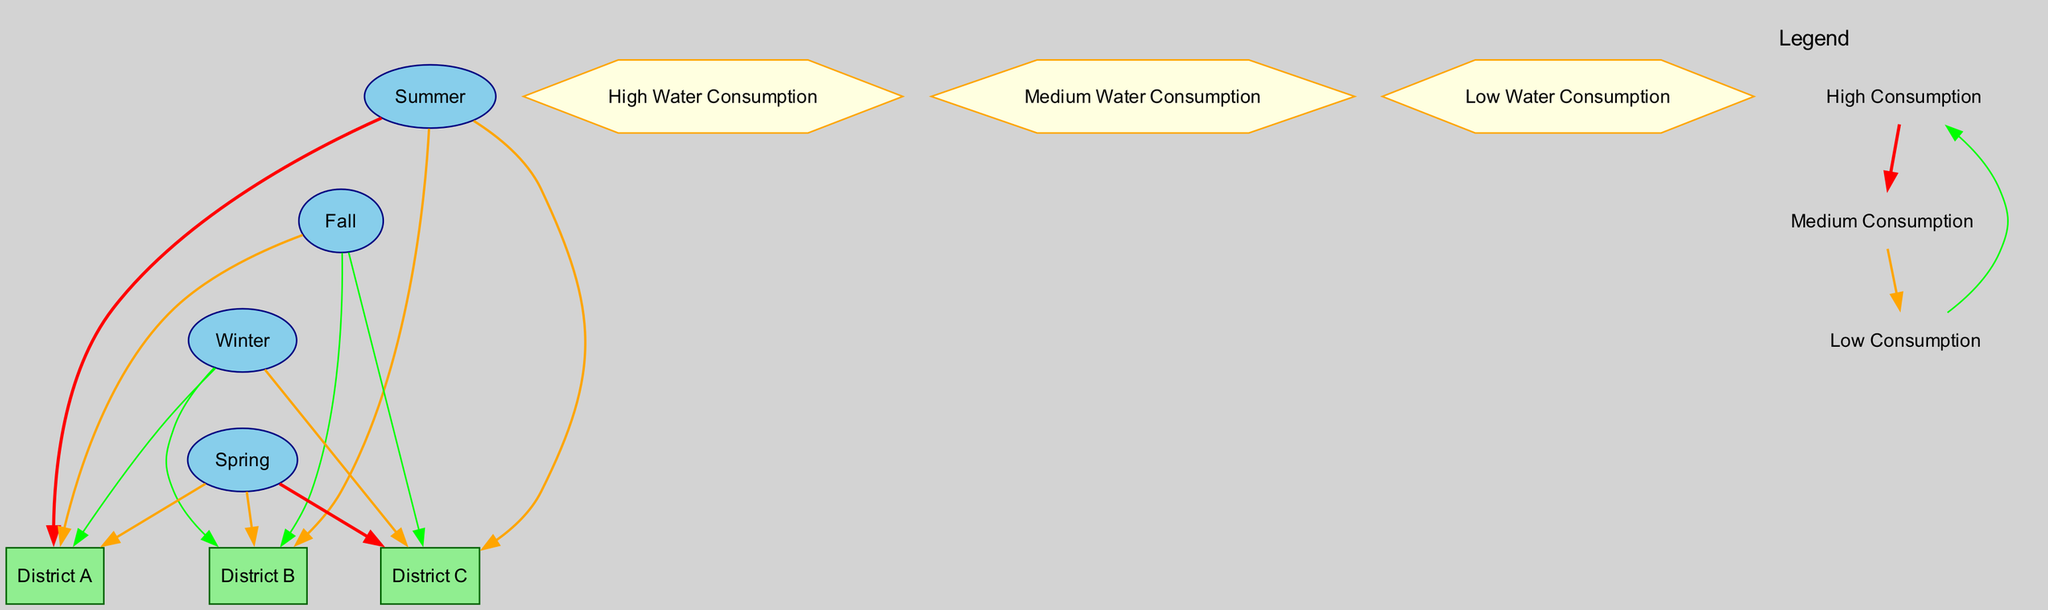What is the water consumption level for District A in Summer? According to the diagram, District A in Summer is connected by an edge labeled "highConsumption". This indicates that the water consumption level in this season for District A is categorized as high.
Answer: High Water Consumption How many districts are represented in the diagram? The diagram displays three districts, which are labeled District A, District B, and District C. Each district is represented by a box node, tallying up to a total of three distinct districts.
Answer: 3 What is the water consumption level for District B in Fall? In the Fall, District B has an edge labeled "lowConsumption" connecting it to the Fall node. Therefore, the water consumption level for District B during the Fall is categorized as low.
Answer: Low Water Consumption Which district has high water consumption during Spring? In Spring, District C has an edge labeled "highConsumption" linking it to the Spring node. This shows that the water consumption for District C in this season is classified as high.
Answer: District C What is the consumption level of District C during Winter? The edge from the Winter node to District C is labeled "mediumConsumption". This indicates that the water consumption level for District C in Winter is classified as medium.
Answer: Medium Water Consumption How many edges connect to District B? The diagram illustrates two edges that connect to District B: one from Summer labeled "mediumConsumption" and one from Fall labeled "lowConsumption". Therefore, District B is linked to a total of two edges.
Answer: 2 Which season has the highest water consumption for District A? By examining the edges linked to District A, Summer is marked with an edge labeled "highConsumption". This indicates that Summer has the highest water consumption for District A compared to other seasons, which are marked with lower consumption levels.
Answer: Summer In which season does District C have the highest water consumption? District C has an edge labeled "highConsumption" linked to Spring, indicating that this is the season when District C's water consumption is highest among all the seasons.
Answer: Spring 